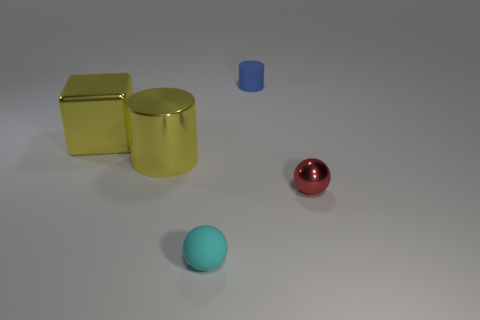Add 1 small blue rubber objects. How many objects exist? 6 Subtract all cylinders. How many objects are left? 3 Subtract 1 blocks. How many blocks are left? 0 Subtract all yellow cylinders. How many cylinders are left? 1 Subtract all green blocks. Subtract all gray cylinders. How many blocks are left? 1 Subtract all yellow balls. How many gray cylinders are left? 0 Subtract all big cyan blocks. Subtract all red metal things. How many objects are left? 4 Add 2 red spheres. How many red spheres are left? 3 Add 5 large gray rubber cubes. How many large gray rubber cubes exist? 5 Subtract 1 cyan balls. How many objects are left? 4 